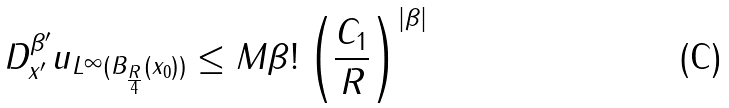<formula> <loc_0><loc_0><loc_500><loc_500>\| D ^ { \beta ^ { \prime } } _ { x ^ { \prime } } u \| _ { L ^ { \infty } ( B _ { \frac { R } { 4 } } ( x _ { 0 } ) ) } \leq M \beta ! \left ( \frac { C _ { 1 } } { R } \right ) ^ { | \beta | }</formula> 